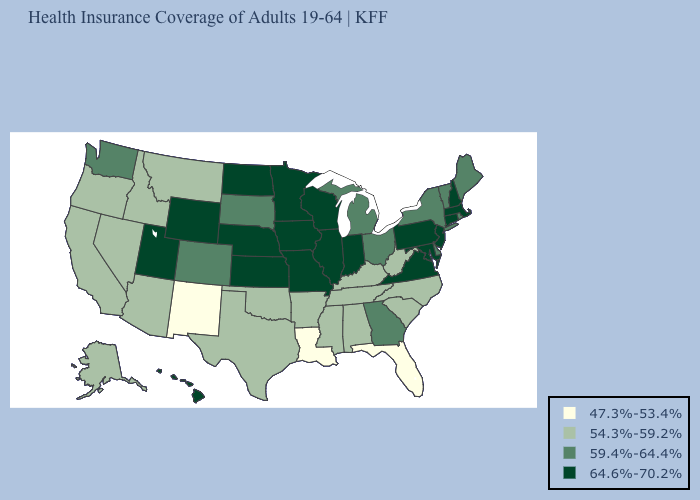Name the states that have a value in the range 59.4%-64.4%?
Answer briefly. Colorado, Delaware, Georgia, Maine, Michigan, New York, Ohio, Rhode Island, South Dakota, Vermont, Washington. What is the lowest value in states that border New York?
Concise answer only. 59.4%-64.4%. What is the value of Michigan?
Write a very short answer. 59.4%-64.4%. Name the states that have a value in the range 54.3%-59.2%?
Concise answer only. Alabama, Alaska, Arizona, Arkansas, California, Idaho, Kentucky, Mississippi, Montana, Nevada, North Carolina, Oklahoma, Oregon, South Carolina, Tennessee, Texas, West Virginia. Name the states that have a value in the range 47.3%-53.4%?
Write a very short answer. Florida, Louisiana, New Mexico. Which states hav the highest value in the MidWest?
Write a very short answer. Illinois, Indiana, Iowa, Kansas, Minnesota, Missouri, Nebraska, North Dakota, Wisconsin. Does Missouri have the lowest value in the MidWest?
Concise answer only. No. Name the states that have a value in the range 64.6%-70.2%?
Keep it brief. Connecticut, Hawaii, Illinois, Indiana, Iowa, Kansas, Maryland, Massachusetts, Minnesota, Missouri, Nebraska, New Hampshire, New Jersey, North Dakota, Pennsylvania, Utah, Virginia, Wisconsin, Wyoming. Which states hav the highest value in the Northeast?
Write a very short answer. Connecticut, Massachusetts, New Hampshire, New Jersey, Pennsylvania. Name the states that have a value in the range 47.3%-53.4%?
Write a very short answer. Florida, Louisiana, New Mexico. Name the states that have a value in the range 64.6%-70.2%?
Quick response, please. Connecticut, Hawaii, Illinois, Indiana, Iowa, Kansas, Maryland, Massachusetts, Minnesota, Missouri, Nebraska, New Hampshire, New Jersey, North Dakota, Pennsylvania, Utah, Virginia, Wisconsin, Wyoming. What is the lowest value in states that border North Dakota?
Short answer required. 54.3%-59.2%. What is the value of New Jersey?
Write a very short answer. 64.6%-70.2%. Does Colorado have a higher value than North Dakota?
Give a very brief answer. No. Which states have the lowest value in the USA?
Give a very brief answer. Florida, Louisiana, New Mexico. 